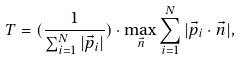Convert formula to latex. <formula><loc_0><loc_0><loc_500><loc_500>T = ( \frac { 1 } { \sum _ { i = 1 } ^ { N } | \vec { p } _ { i } | } ) \cdot \max _ { \vec { n } } \sum _ { i = 1 } ^ { N } | \vec { p } _ { i } \cdot \vec { n } | ,</formula> 